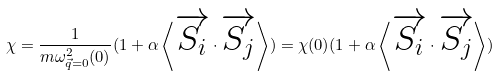<formula> <loc_0><loc_0><loc_500><loc_500>\chi = \frac { 1 } { { m \omega _ { \vec { q } = 0 } ^ { 2 } ( 0 ) } } ( 1 + \alpha \left \langle { \overrightarrow { S _ { i } } \cdot \overrightarrow { S _ { j } } } \right \rangle ) = \chi ( 0 ) ( 1 + \alpha \left \langle { \overrightarrow { S _ { i } } \cdot \overrightarrow { S _ { j } } } \right \rangle )</formula> 